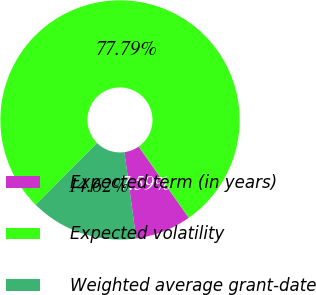<chart> <loc_0><loc_0><loc_500><loc_500><pie_chart><fcel>Expected term (in years)<fcel>Expected volatility<fcel>Weighted average grant-date<nl><fcel>7.59%<fcel>77.79%<fcel>14.62%<nl></chart> 